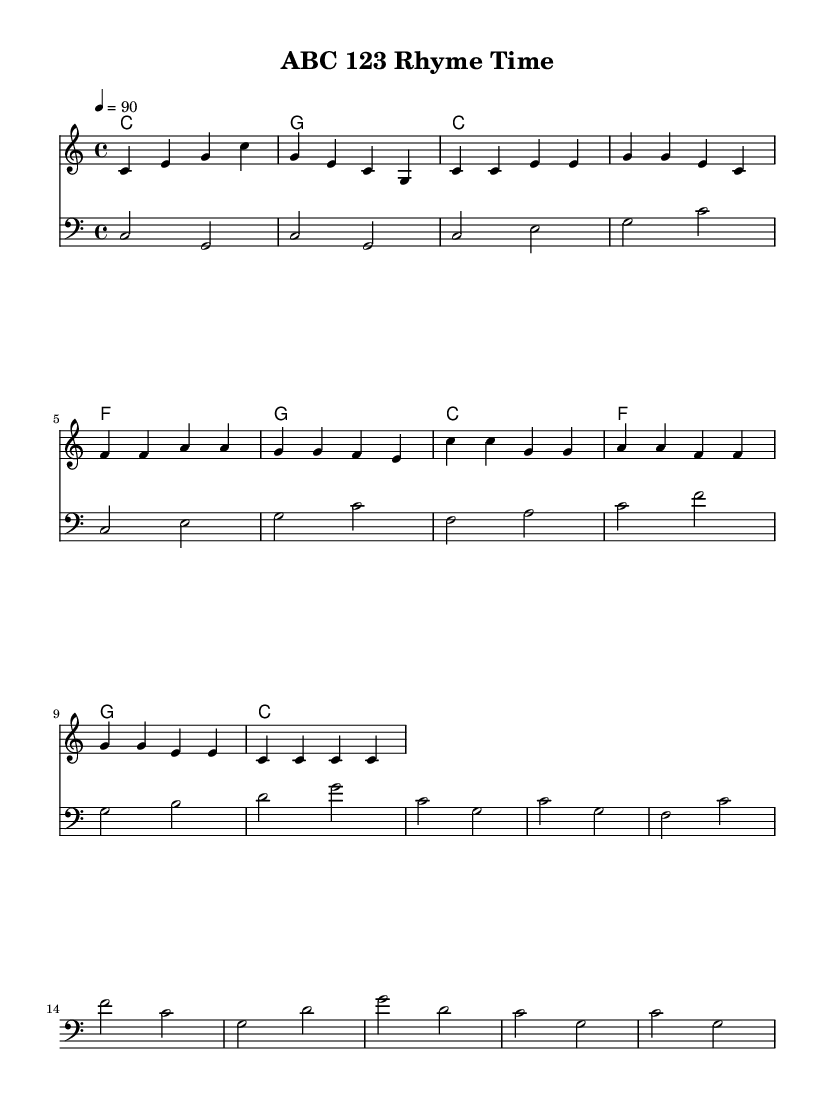What is the key signature of this music? The key signature is C major, which has no sharps or flats.
Answer: C major What is the time signature of this music? The time signature is indicated by the fraction at the beginning of the sheet music, showing that there are four beats per measure and the quarter note gets one beat.
Answer: 4/4 What is the tempo marking for this piece? The tempo marking is found at the beginning of the score, specifying the speed at which the piece should be performed, indicated as quarter note equals ninety beats per minute.
Answer: 90 How many measures are in the verse section of the song? The verse section can be identified by counting the measures within the marked section, which consists of 4 measures total.
Answer: 4 What is the structure of the song? Analyzing the sections labeled as Intro, Verse, and Chorus, the structure can be summarized to show a clear pattern of introduction, followed by the verse, and then the repeated chorus.
Answer: Intro, Verse, Chorus Which section of the song contains repeated notes prominently? By observing the melody and counting the occurrences, the chorus section features repeated notes such as C and G appearing multiple times, making it recognizable.
Answer: Chorus What type of music is this piece classified as? The content and style, including the focus on teaching with a rhythmic and catchy flow typical of rap music, determine that it falls under educational hip-hop aimed at teaching letters and numbers.
Answer: Educational hip-hop 